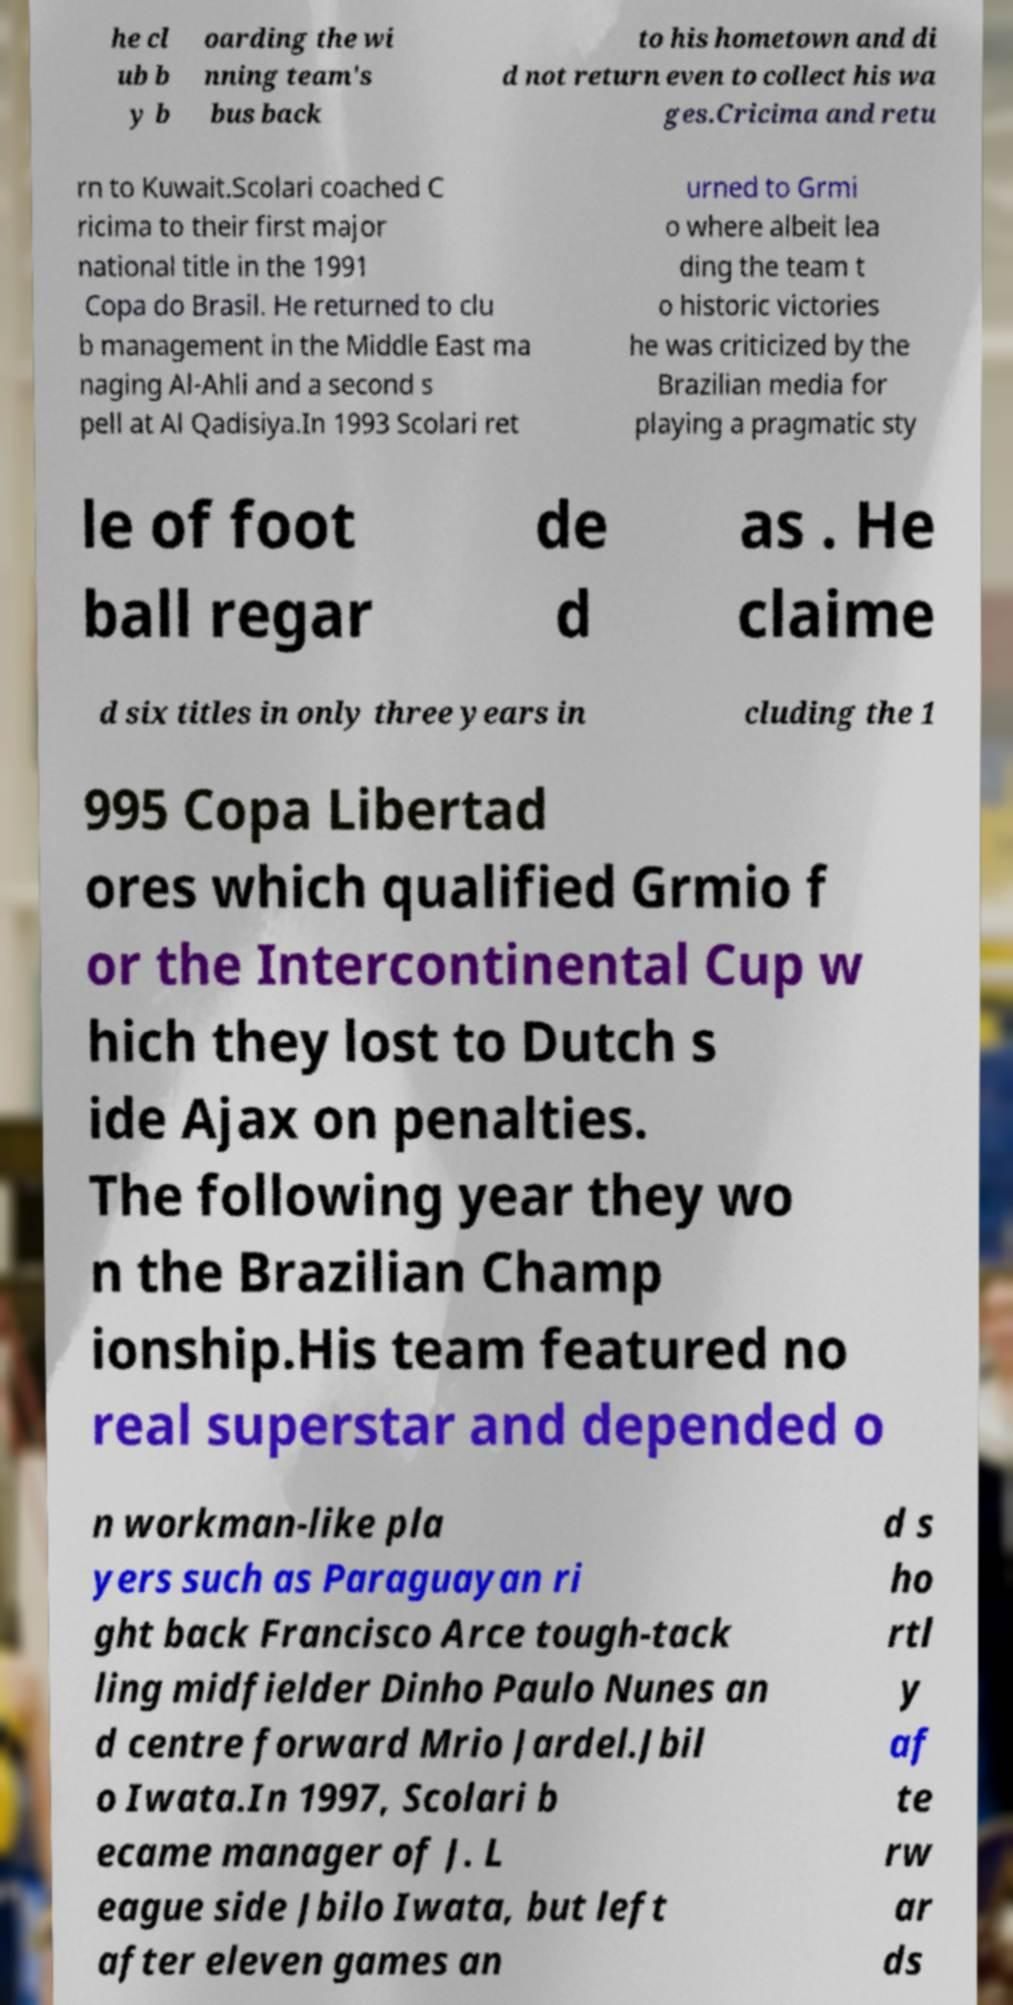Could you assist in decoding the text presented in this image and type it out clearly? he cl ub b y b oarding the wi nning team's bus back to his hometown and di d not return even to collect his wa ges.Cricima and retu rn to Kuwait.Scolari coached C ricima to their first major national title in the 1991 Copa do Brasil. He returned to clu b management in the Middle East ma naging Al-Ahli and a second s pell at Al Qadisiya.In 1993 Scolari ret urned to Grmi o where albeit lea ding the team t o historic victories he was criticized by the Brazilian media for playing a pragmatic sty le of foot ball regar de d as . He claime d six titles in only three years in cluding the 1 995 Copa Libertad ores which qualified Grmio f or the Intercontinental Cup w hich they lost to Dutch s ide Ajax on penalties. The following year they wo n the Brazilian Champ ionship.His team featured no real superstar and depended o n workman-like pla yers such as Paraguayan ri ght back Francisco Arce tough-tack ling midfielder Dinho Paulo Nunes an d centre forward Mrio Jardel.Jbil o Iwata.In 1997, Scolari b ecame manager of J. L eague side Jbilo Iwata, but left after eleven games an d s ho rtl y af te rw ar ds 